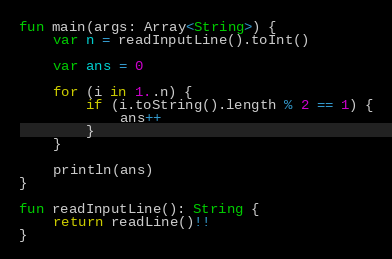<code> <loc_0><loc_0><loc_500><loc_500><_Kotlin_>fun main(args: Array<String>) {
    var n = readInputLine().toInt()
    
    var ans = 0
    
    for (i in 1..n) {
        if (i.toString().length % 2 == 1) {
            ans++
        }
    }
    
    println(ans)
}

fun readInputLine(): String {
    return readLine()!!
}
</code> 